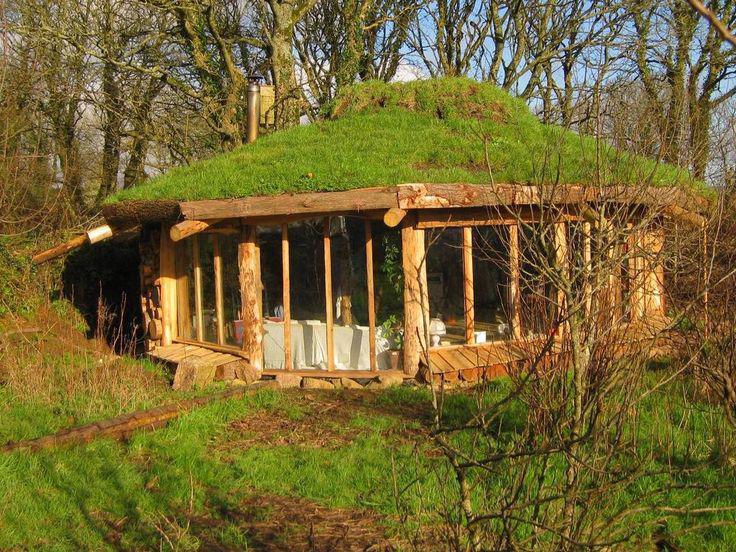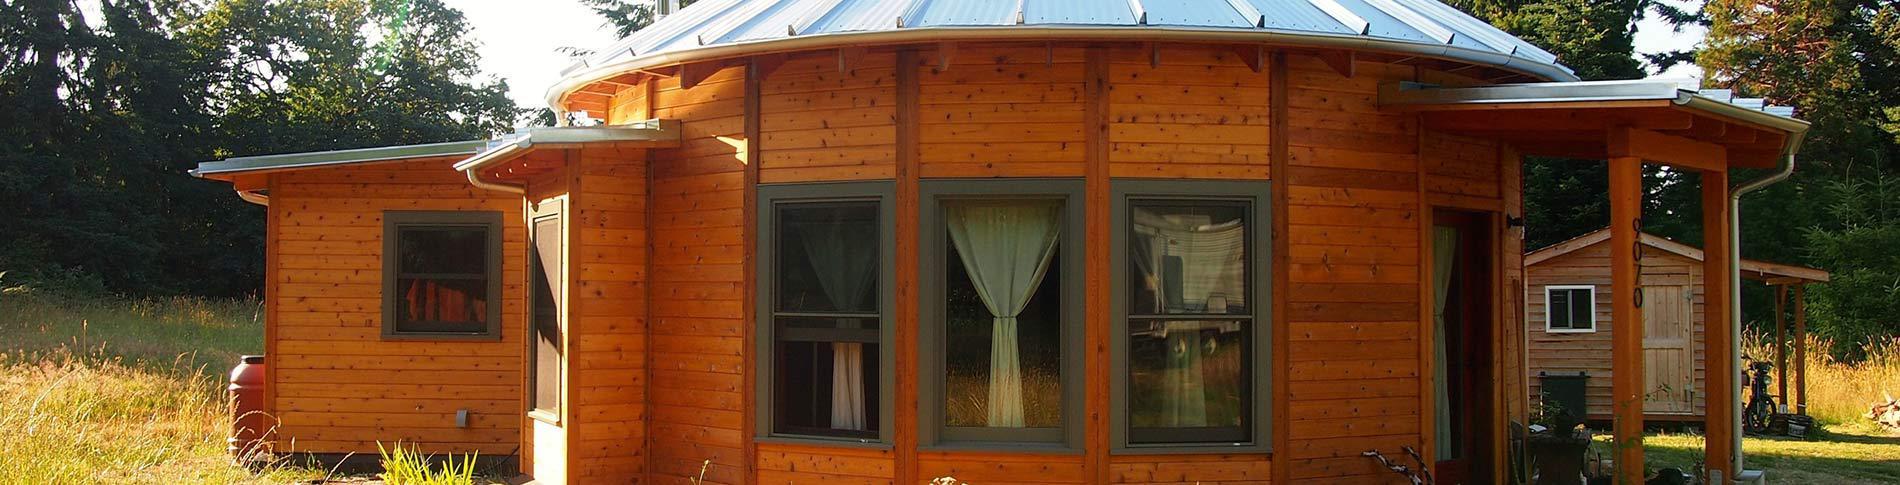The first image is the image on the left, the second image is the image on the right. Examine the images to the left and right. Is the description "All images show only the exteriors of homes." accurate? Answer yes or no. Yes. 